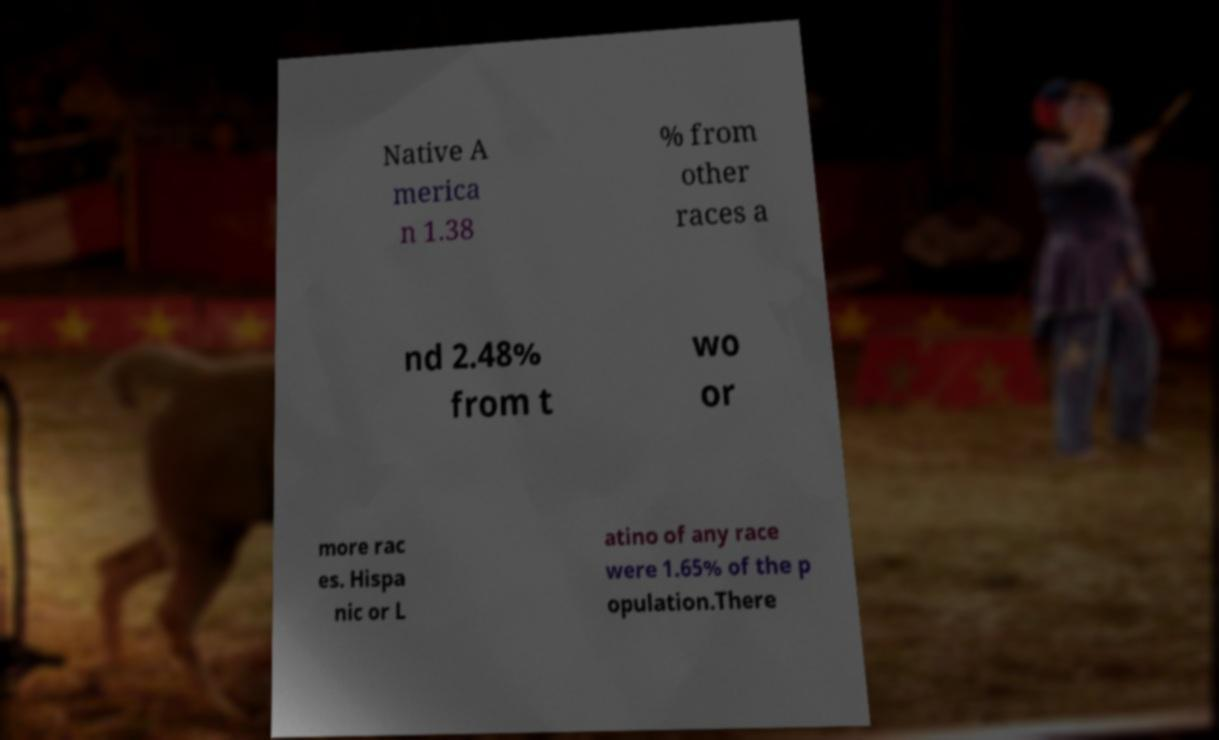I need the written content from this picture converted into text. Can you do that? Native A merica n 1.38 % from other races a nd 2.48% from t wo or more rac es. Hispa nic or L atino of any race were 1.65% of the p opulation.There 